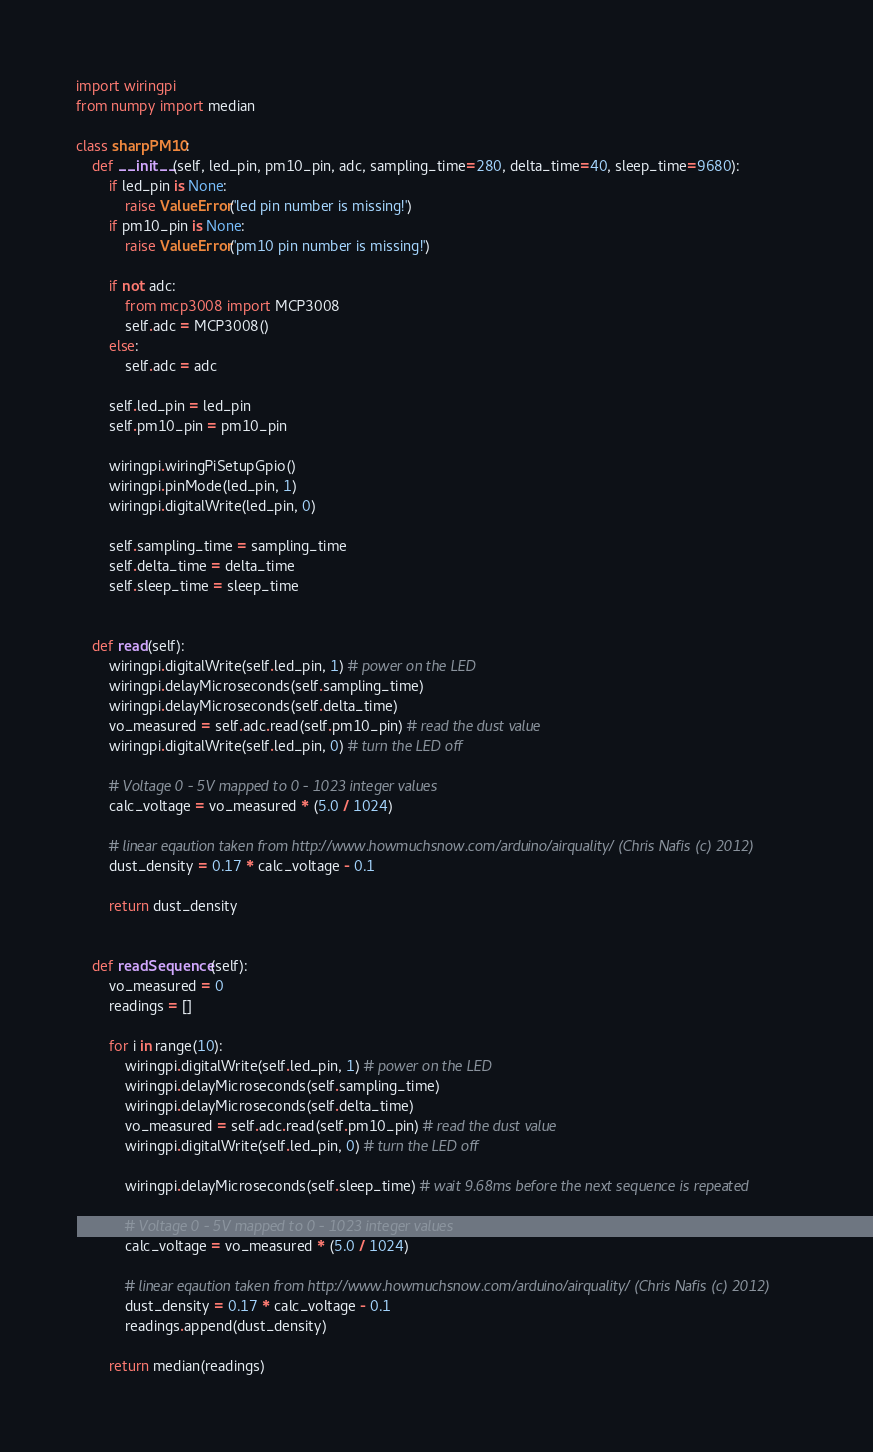<code> <loc_0><loc_0><loc_500><loc_500><_Python_>import wiringpi
from numpy import median

class sharpPM10:
    def __init__(self, led_pin, pm10_pin, adc, sampling_time=280, delta_time=40, sleep_time=9680):
        if led_pin is None:
            raise ValueError('led pin number is missing!')
        if pm10_pin is None:
            raise ValueError('pm10 pin number is missing!')

        if not adc:
            from mcp3008 import MCP3008
            self.adc = MCP3008()
        else:
            self.adc = adc

        self.led_pin = led_pin
        self.pm10_pin = pm10_pin

        wiringpi.wiringPiSetupGpio()
        wiringpi.pinMode(led_pin, 1)
        wiringpi.digitalWrite(led_pin, 0)

        self.sampling_time = sampling_time
        self.delta_time = delta_time
        self.sleep_time = sleep_time

    
    def read(self):
        wiringpi.digitalWrite(self.led_pin, 1) # power on the LED
        wiringpi.delayMicroseconds(self.sampling_time)
        wiringpi.delayMicroseconds(self.delta_time)
        vo_measured = self.adc.read(self.pm10_pin) # read the dust value
        wiringpi.digitalWrite(self.led_pin, 0) # turn the LED off

        # Voltage 0 - 5V mapped to 0 - 1023 integer values
        calc_voltage = vo_measured * (5.0 / 1024)

        # linear eqaution taken from http://www.howmuchsnow.com/arduino/airquality/ (Chris Nafis (c) 2012)
        dust_density = 0.17 * calc_voltage - 0.1

        return dust_density


    def readSequence(self):
        vo_measured = 0
        readings = []

        for i in range(10):
            wiringpi.digitalWrite(self.led_pin, 1) # power on the LED
            wiringpi.delayMicroseconds(self.sampling_time)
            wiringpi.delayMicroseconds(self.delta_time)
            vo_measured = self.adc.read(self.pm10_pin) # read the dust value
            wiringpi.digitalWrite(self.led_pin, 0) # turn the LED off

            wiringpi.delayMicroseconds(self.sleep_time) # wait 9.68ms before the next sequence is repeated

            # Voltage 0 - 5V mapped to 0 - 1023 integer values
            calc_voltage = vo_measured * (5.0 / 1024)

            # linear eqaution taken from http://www.howmuchsnow.com/arduino/airquality/ (Chris Nafis (c) 2012)
            dust_density = 0.17 * calc_voltage - 0.1
            readings.append(dust_density)

        return median(readings)
</code> 